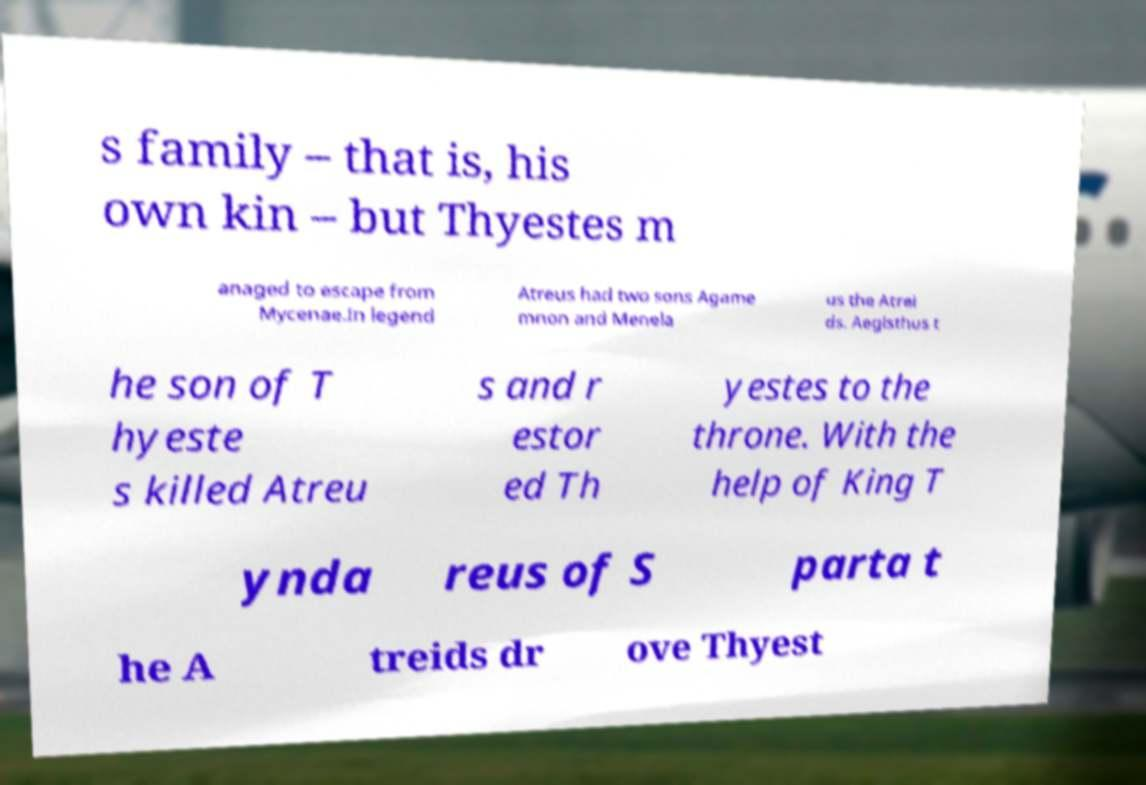There's text embedded in this image that I need extracted. Can you transcribe it verbatim? s family – that is, his own kin – but Thyestes m anaged to escape from Mycenae.In legend Atreus had two sons Agame mnon and Menela us the Atrei ds. Aegisthus t he son of T hyeste s killed Atreu s and r estor ed Th yestes to the throne. With the help of King T ynda reus of S parta t he A treids dr ove Thyest 